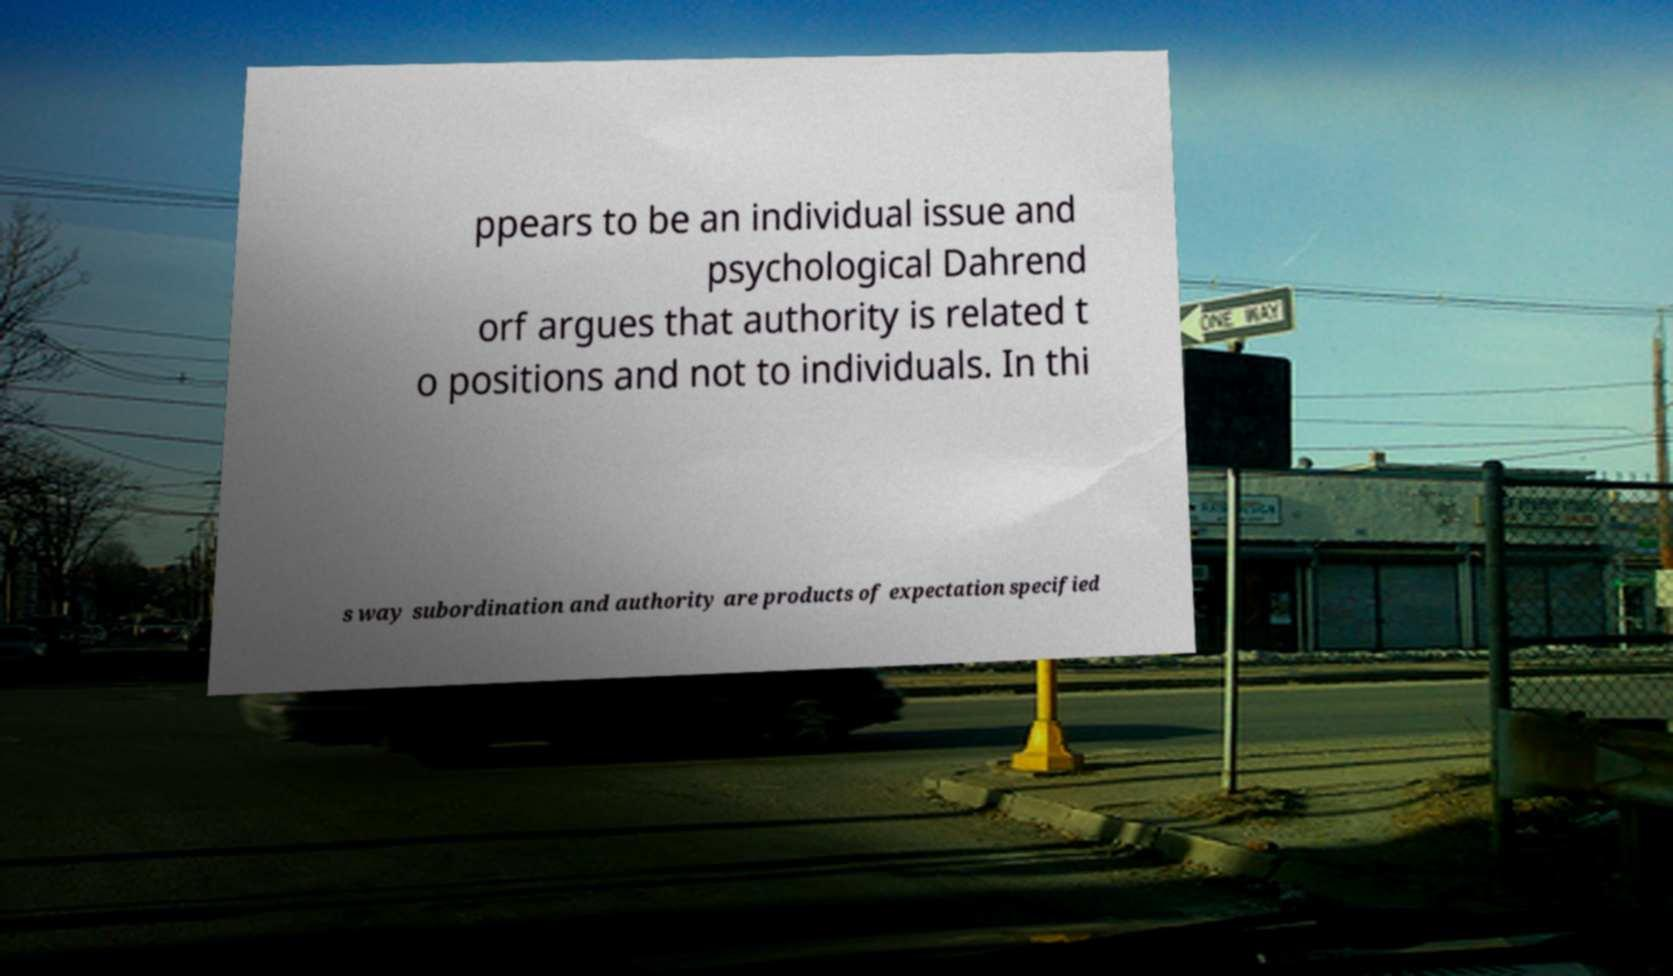Can you read and provide the text displayed in the image?This photo seems to have some interesting text. Can you extract and type it out for me? ppears to be an individual issue and psychological Dahrend orf argues that authority is related t o positions and not to individuals. In thi s way subordination and authority are products of expectation specified 